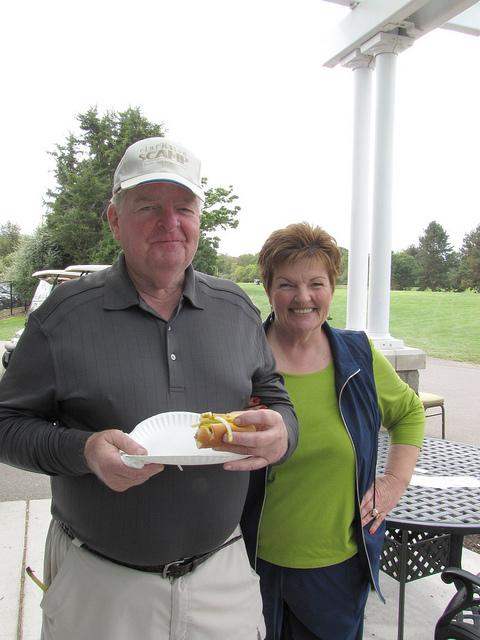What type of fruit is he holding?
Quick response, please. Apple. What logo is on the man's hat?
Give a very brief answer. Scamp. What is the plate made out of?
Quick response, please. Paper. Who is eating?
Write a very short answer. Man. What is he holding, besides the hot dog?
Write a very short answer. Plate. 